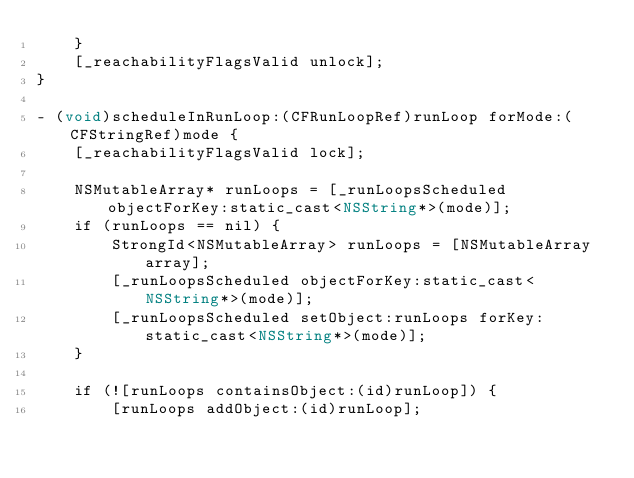<code> <loc_0><loc_0><loc_500><loc_500><_ObjectiveC_>    }
    [_reachabilityFlagsValid unlock];
}

- (void)scheduleInRunLoop:(CFRunLoopRef)runLoop forMode:(CFStringRef)mode {
    [_reachabilityFlagsValid lock];

    NSMutableArray* runLoops = [_runLoopsScheduled objectForKey:static_cast<NSString*>(mode)];
    if (runLoops == nil) {
        StrongId<NSMutableArray> runLoops = [NSMutableArray array];
        [_runLoopsScheduled objectForKey:static_cast<NSString*>(mode)];
        [_runLoopsScheduled setObject:runLoops forKey:static_cast<NSString*>(mode)];
    }

    if (![runLoops containsObject:(id)runLoop]) {
        [runLoops addObject:(id)runLoop];</code> 